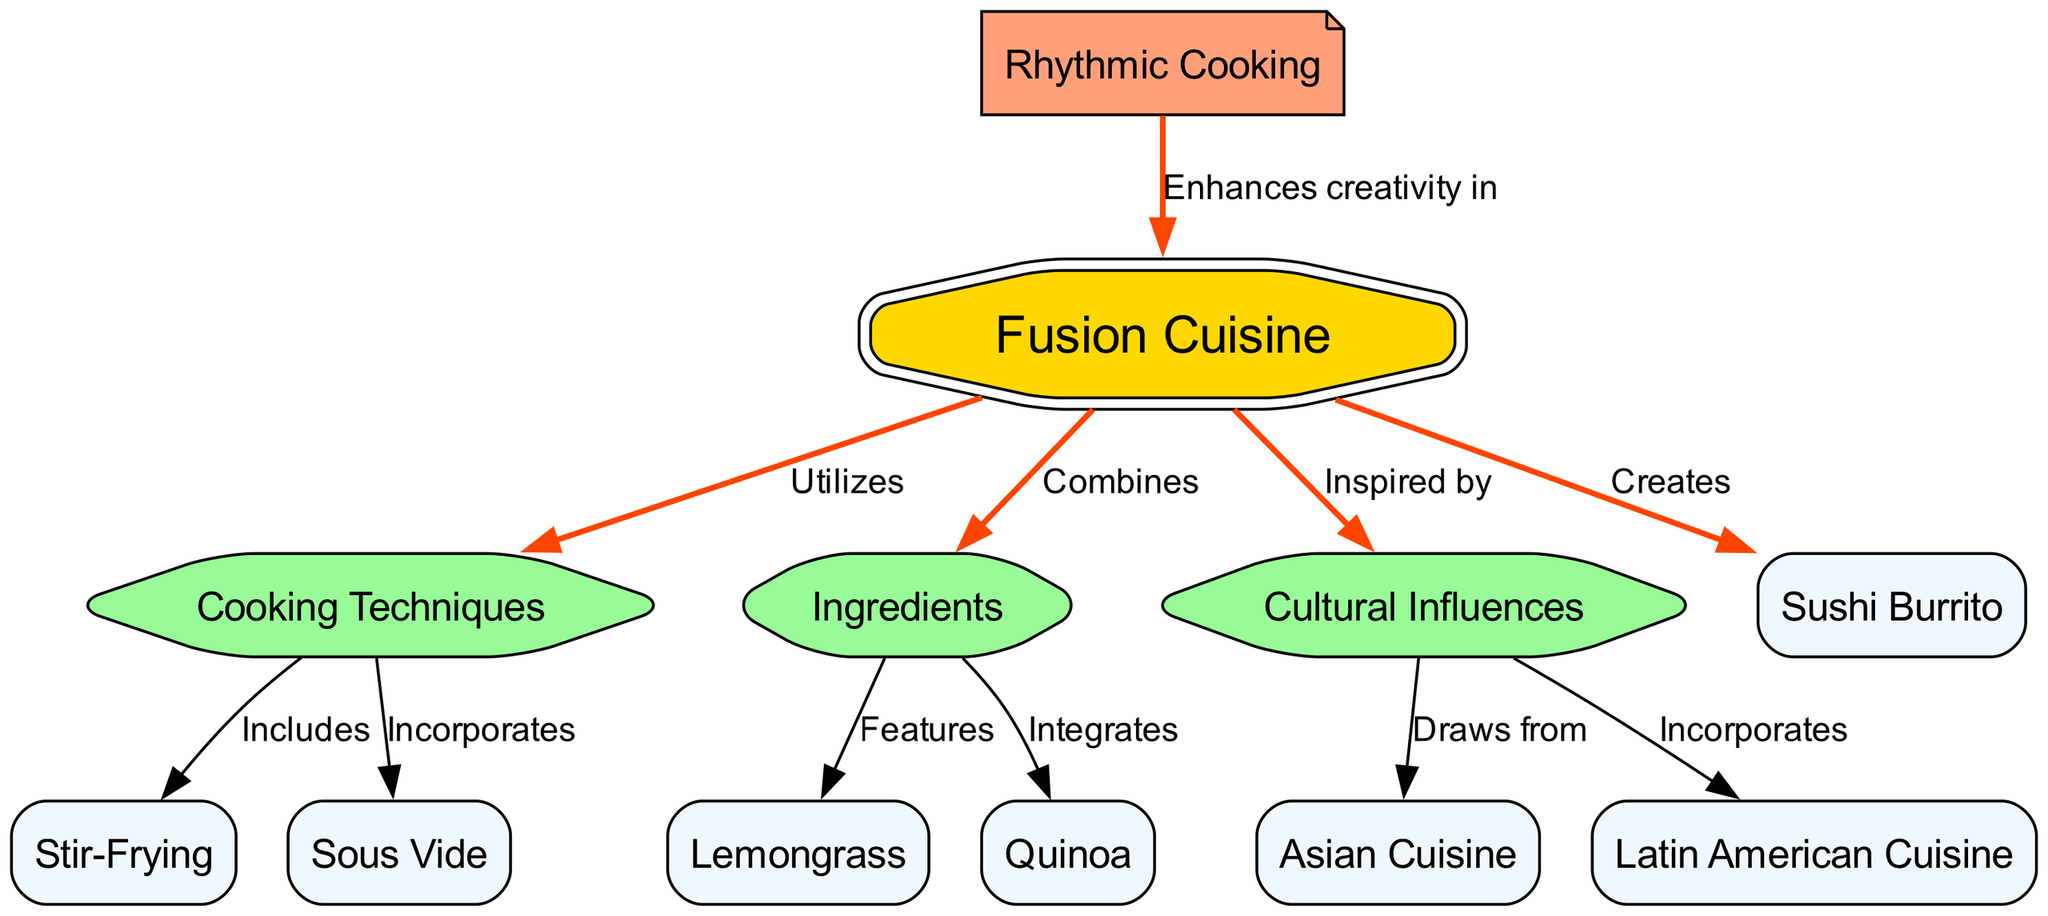What is the central theme of the diagram? The central theme is identified by the main node, which is labeled "Fusion Cuisine." It serves as the starting point for various connections that branch out to other themes.
Answer: Fusion Cuisine How many cooking techniques are depicted in the diagram? By examining the nodes connected to the "Cooking Techniques" node, we find two distinct techniques: "Stir-Frying" and "Sous Vide." Therefore, we count these techniques and find that there are two.
Answer: 2 Which ingredient is featured in the diagram? The "Ingredients" node connects to "Lemongrass" and "Quinoa." Since both are linked to the "Ingredients" node, they represent featured items, but the question asks for one specific ingredient, which can be identified straightforwardly as "Lemongrass."
Answer: Lemongrass What cultural influence does the diagram incorporate? The "Cultural Influences" node shows connections to "Asian Cuisine" and "Latin American Cuisine." Since the question asks for a single cultural influence, we can choose either, but directly from the node options, "Asian" stands out as a clear cultural influence mentioned.
Answer: Asian Cuisine How does rhythm enhance fusion cuisine? According to the edges leading from "Rhythm," it specifically states that rhythm "Enhances creativity in" fusion cuisine. This indicates a direct influence where rhythm plays a role in the creative process of fusion cooking.
Answer: Enhances creativity in What type of edge connects cooking techniques to stir-frying? The edge between "Cooking Techniques" and "Stir-Frying" states "Includes." This descriptive label indicates the nature of the relationship, reflecting that stir-frying is a technique included in the broader category of cooking techniques.
Answer: Includes What type of cooking technique incorporates sous vide? The edge points from "Cooking Techniques" to "Sous Vide" and states "Incorporates." This labeling shows that sous vide is an example of a technique that is part of this larger classification of cooking techniques.
Answer: Incorporates How many elements does the fusion cuisine branch connect to? The "Fusion Cuisine" node connects to three primary branches: "Cooking Techniques," "Ingredients," and "Cultural Influences." Additionally, it also connects to the unique creation of "Sushi Burrito," leading to a total of four connected elements.
Answer: 4 